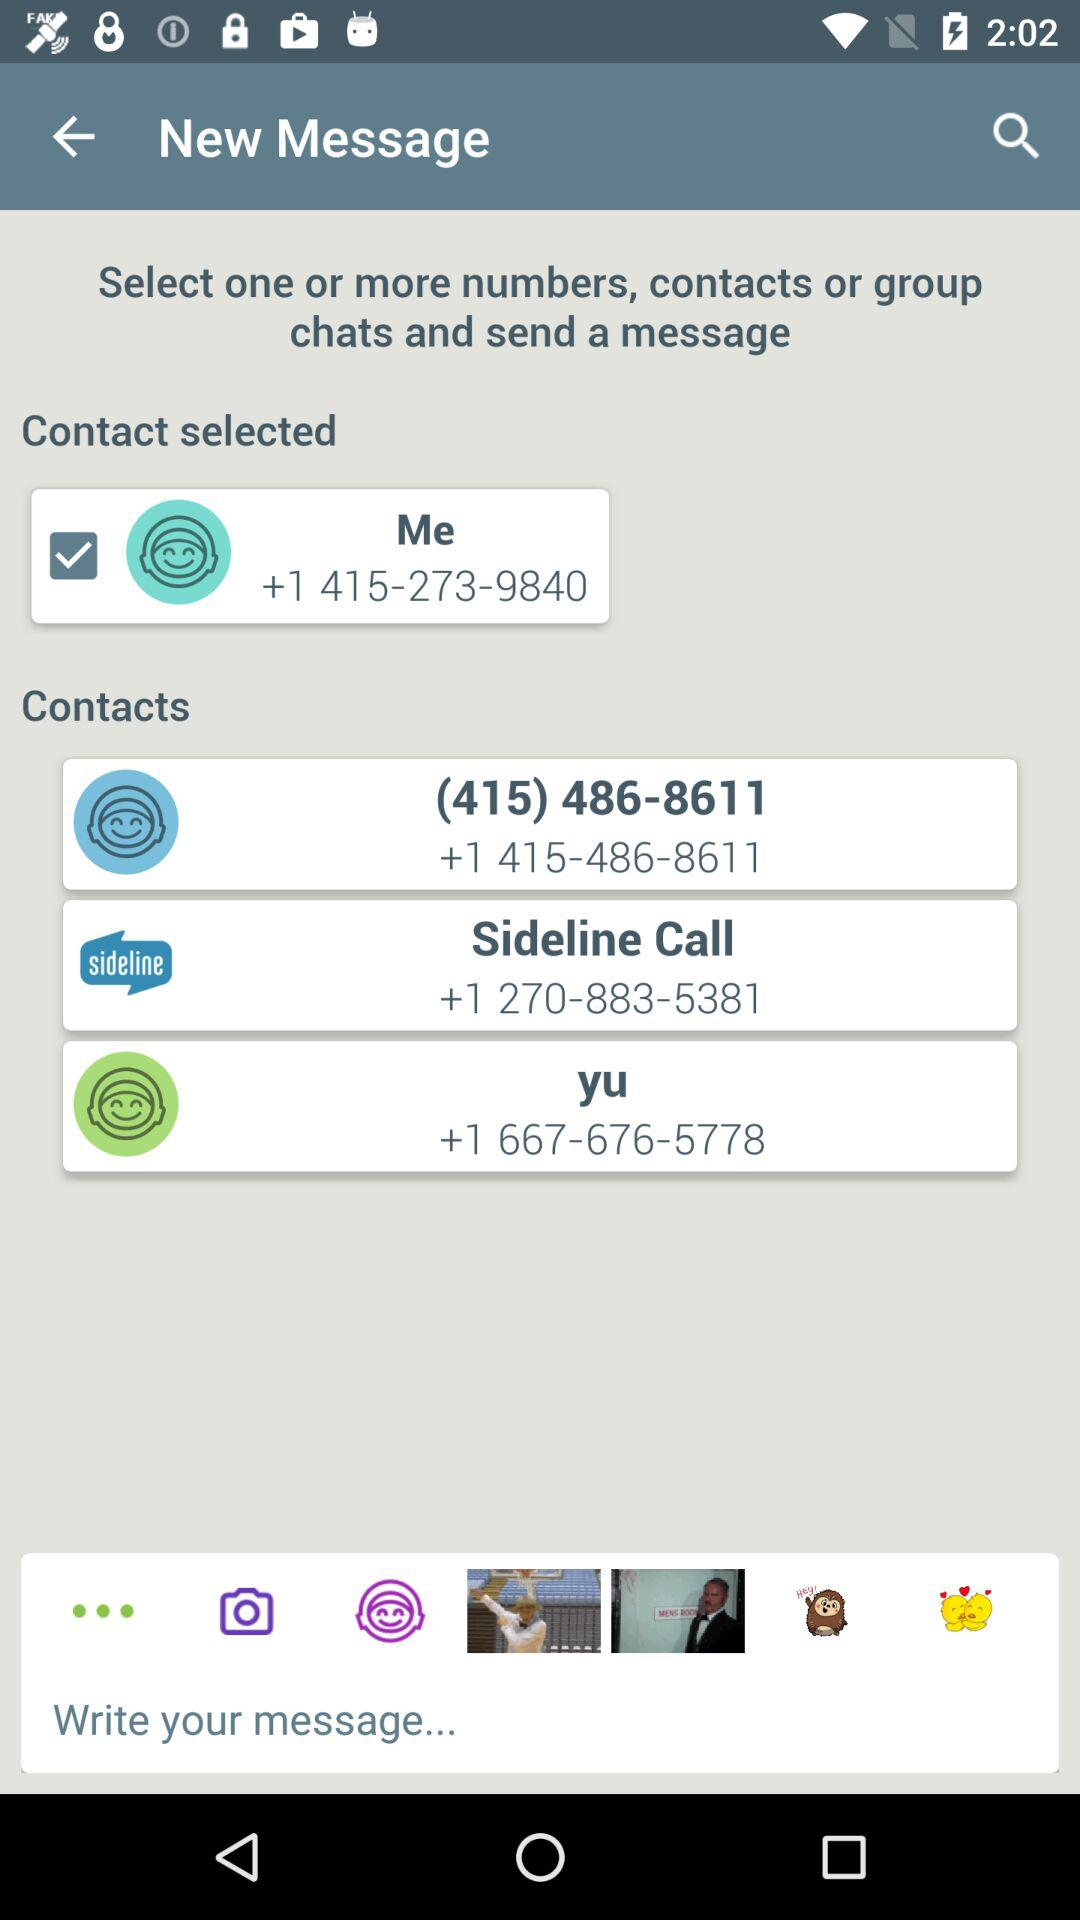What is the mentioned number for "yu"? The mentioned number for "yu" is +1 667-676-5778. 